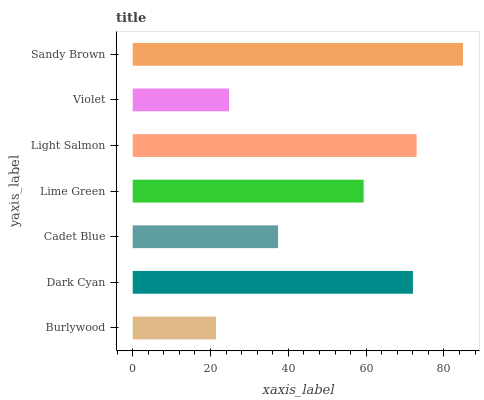Is Burlywood the minimum?
Answer yes or no. Yes. Is Sandy Brown the maximum?
Answer yes or no. Yes. Is Dark Cyan the minimum?
Answer yes or no. No. Is Dark Cyan the maximum?
Answer yes or no. No. Is Dark Cyan greater than Burlywood?
Answer yes or no. Yes. Is Burlywood less than Dark Cyan?
Answer yes or no. Yes. Is Burlywood greater than Dark Cyan?
Answer yes or no. No. Is Dark Cyan less than Burlywood?
Answer yes or no. No. Is Lime Green the high median?
Answer yes or no. Yes. Is Lime Green the low median?
Answer yes or no. Yes. Is Burlywood the high median?
Answer yes or no. No. Is Sandy Brown the low median?
Answer yes or no. No. 